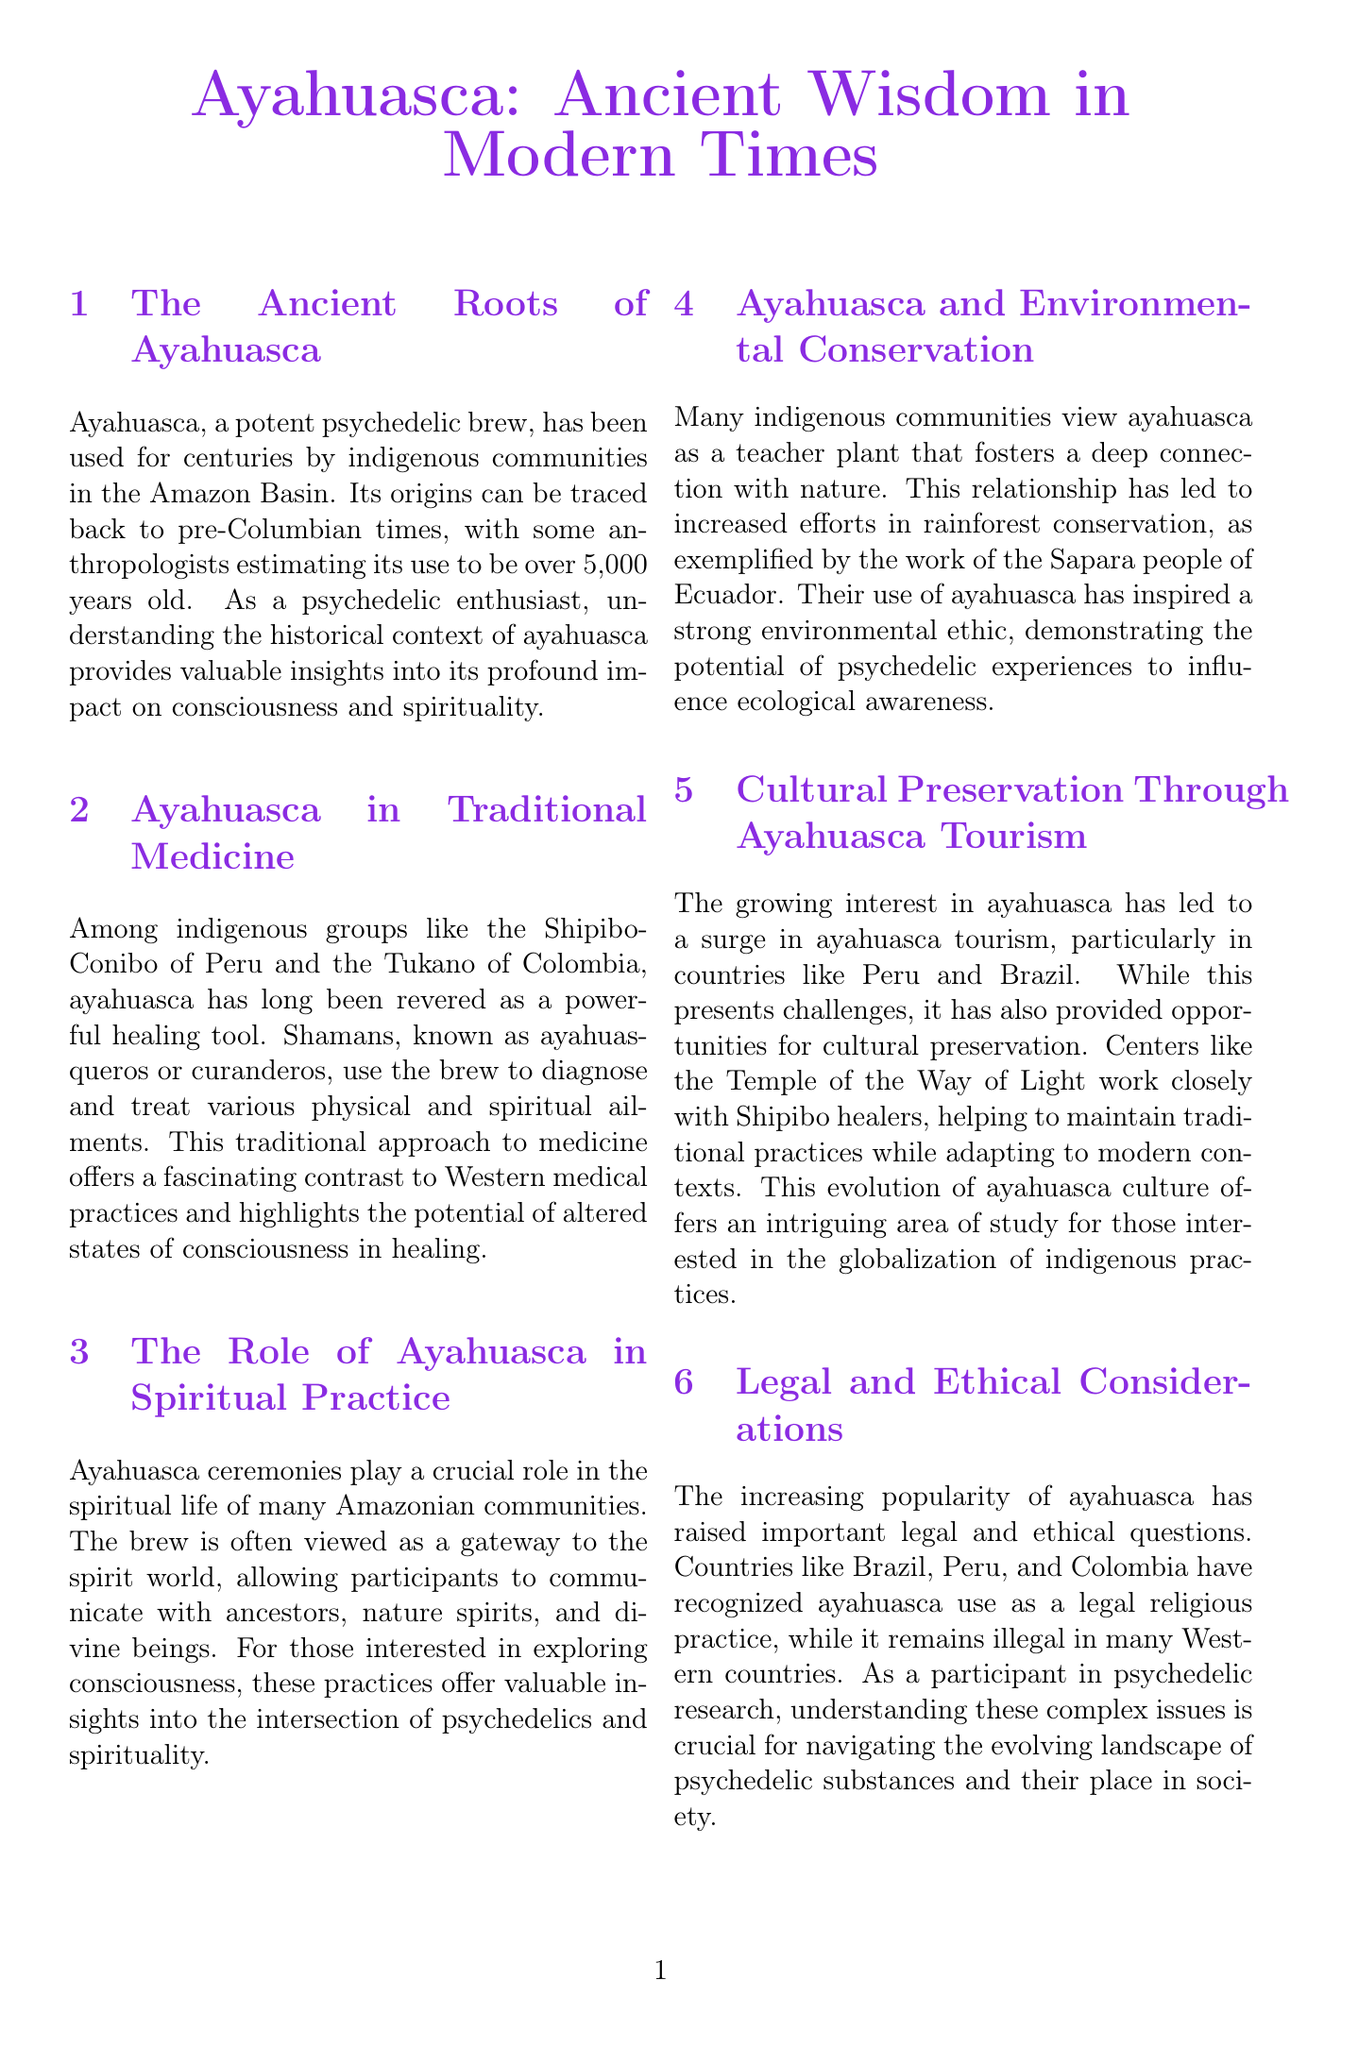What is the estimated age of ayahuasca use? The document states that some anthropologists estimate its use to be over 5,000 years old.
Answer: over 5,000 years old Who are the shamans that use ayahuasca? The document refers to shamans as ayahuasqueros or curanderos in indigenous groups.
Answer: ayahuasqueros or curanderos Which indigenous group is mentioned in relation to environmental conservation? The document specifically mentions the Sapara people of Ecuador in this context.
Answer: Sapara people What is ayahuasca often viewed as in spiritual practice? The document states that ayahuasca is often viewed as a gateway to the spirit world.
Answer: gateway to the spirit world What legal status does ayahuasca have in Brazil? The document mentions that ayahuasca use is recognized as a legal religious practice in Brazil.
Answer: legal religious practice Who is the expert quoted in the document? The expert opinion section cites Dr. Dennis McKenna.
Answer: Dr. Dennis McKenna What are the names of the editors of the recommended reading on ayahuasca? The document lists Luis Eduardo Luna and Steven F. White as the editors.
Answer: Luis Eduardo Luna and Steven F. White What is one of the roles of ayahuasca in traditional medicine? The document states that ayahuasca is used to diagnose and treat various physical and spiritual ailments.
Answer: diagnose and treat ailments What does the growth of ayahuasca tourism offer? The document indicates that ayahuasca tourism provides opportunities for cultural preservation.
Answer: opportunities for cultural preservation 